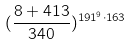<formula> <loc_0><loc_0><loc_500><loc_500>( \frac { 8 + 4 1 3 } { 3 4 0 } ) ^ { 1 9 1 ^ { 9 } \cdot 1 6 3 }</formula> 